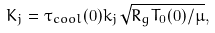Convert formula to latex. <formula><loc_0><loc_0><loc_500><loc_500>K _ { j } = \tau _ { c o o l } ( 0 ) k _ { j } \sqrt { R _ { g } T _ { 0 } ( 0 ) / \mu } ,</formula> 